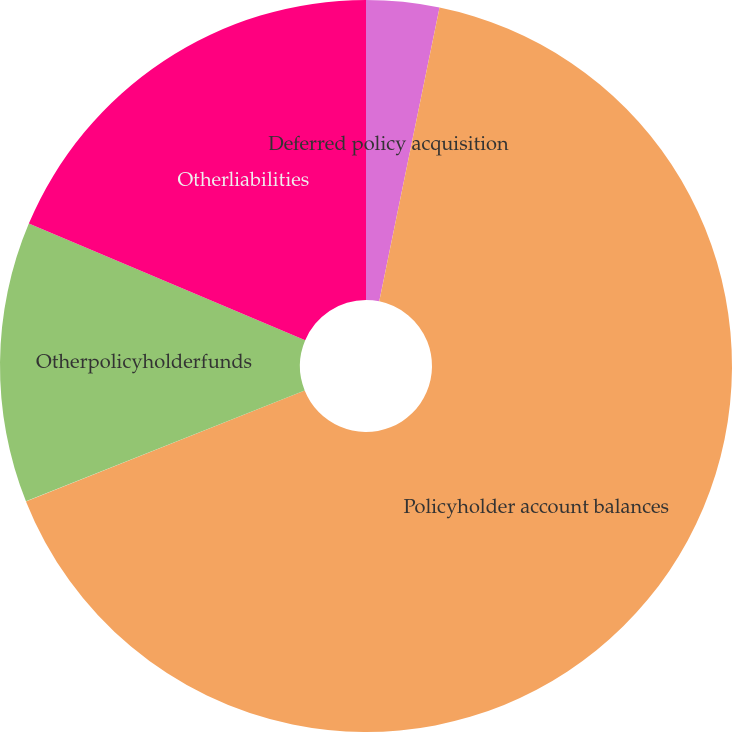Convert chart. <chart><loc_0><loc_0><loc_500><loc_500><pie_chart><fcel>Deferred policy acquisition<fcel>Policyholder account balances<fcel>Otherpolicyholderfunds<fcel>Otherliabilities<nl><fcel>3.22%<fcel>65.75%<fcel>12.39%<fcel>18.64%<nl></chart> 